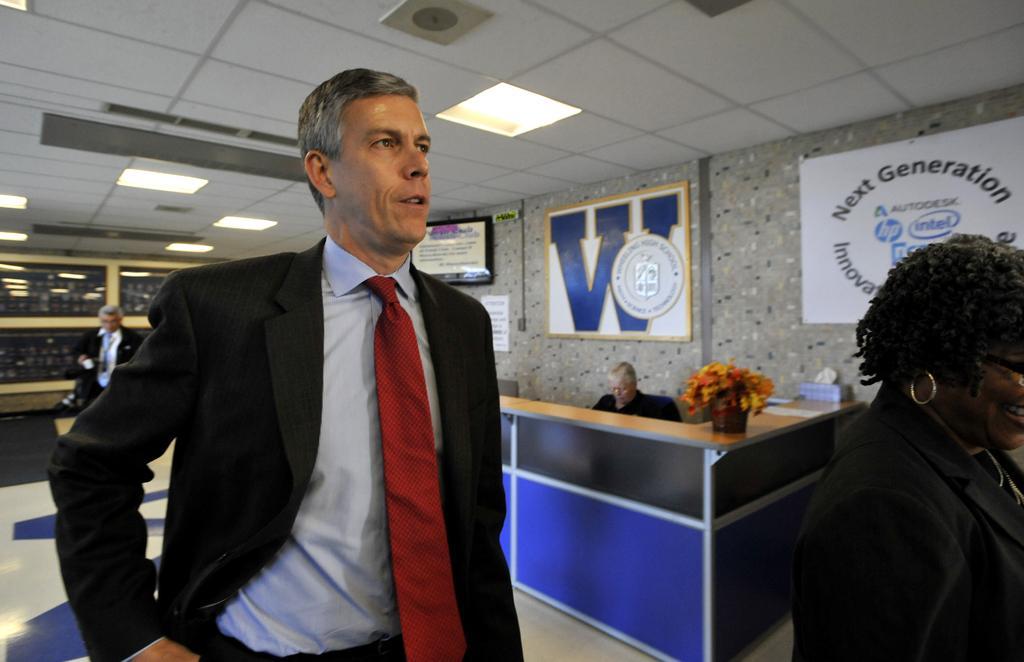Can you describe this image briefly? In this image, there is an inside view of a building. There is a person on the left side of the image wearing clothes. There is an another person in the bottom left of the image standing and wearing clothes. There are some lights at the top. There is a person sitting in a cabin in the center of the image. 